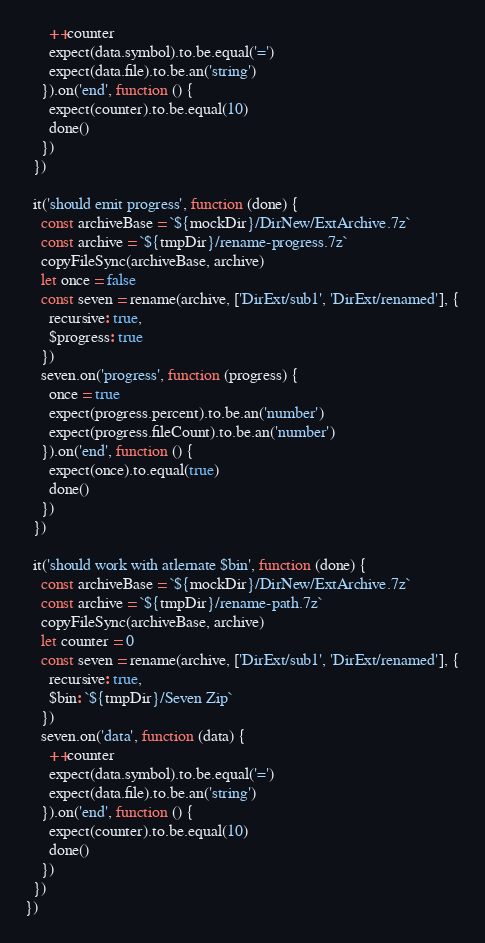Convert code to text. <code><loc_0><loc_0><loc_500><loc_500><_JavaScript_>      ++counter
      expect(data.symbol).to.be.equal('=')
      expect(data.file).to.be.an('string')
    }).on('end', function () {
      expect(counter).to.be.equal(10)
      done()
    })
  })

  it('should emit progress', function (done) {
    const archiveBase = `${mockDir}/DirNew/ExtArchive.7z`
    const archive = `${tmpDir}/rename-progress.7z`
    copyFileSync(archiveBase, archive)
    let once = false
    const seven = rename(archive, ['DirExt/sub1', 'DirExt/renamed'], {
      recursive: true,
      $progress: true
    })
    seven.on('progress', function (progress) {
      once = true
      expect(progress.percent).to.be.an('number')
      expect(progress.fileCount).to.be.an('number')
    }).on('end', function () {
      expect(once).to.equal(true)
      done()
    })
  })

  it('should work with atlernate $bin', function (done) {
    const archiveBase = `${mockDir}/DirNew/ExtArchive.7z`
    const archive = `${tmpDir}/rename-path.7z`
    copyFileSync(archiveBase, archive)
    let counter = 0
    const seven = rename(archive, ['DirExt/sub1', 'DirExt/renamed'], {
      recursive: true,
      $bin: `${tmpDir}/Seven Zip`
    })
    seven.on('data', function (data) {
      ++counter
      expect(data.symbol).to.be.equal('=')
      expect(data.file).to.be.an('string')
    }).on('end', function () {
      expect(counter).to.be.equal(10)
      done()
    })
  })
})
</code> 